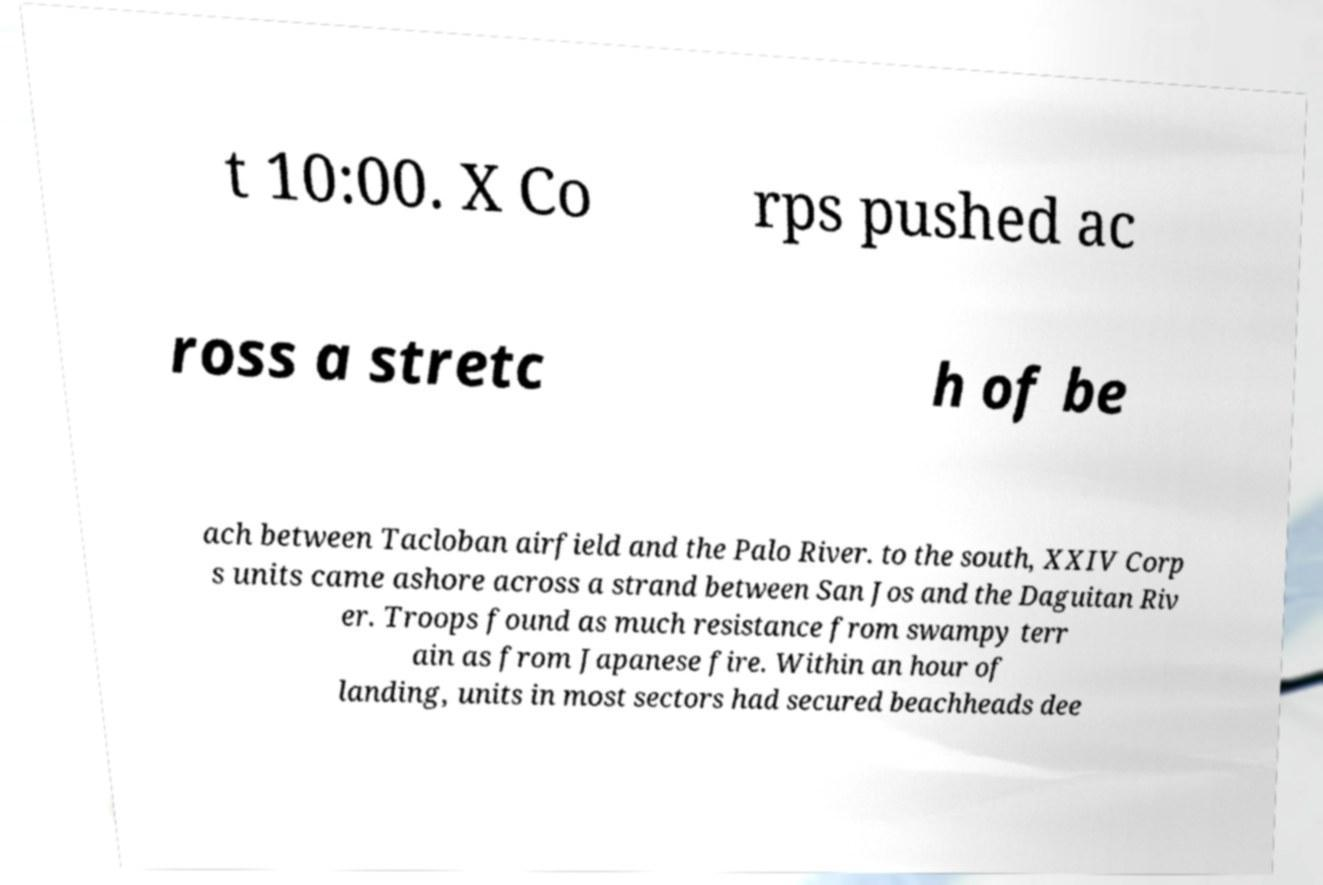Can you accurately transcribe the text from the provided image for me? t 10:00. X Co rps pushed ac ross a stretc h of be ach between Tacloban airfield and the Palo River. to the south, XXIV Corp s units came ashore across a strand between San Jos and the Daguitan Riv er. Troops found as much resistance from swampy terr ain as from Japanese fire. Within an hour of landing, units in most sectors had secured beachheads dee 